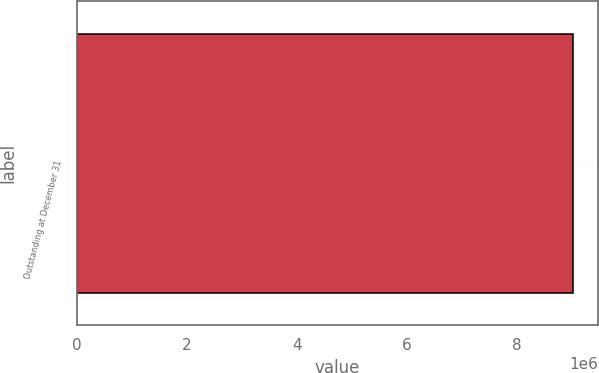<chart> <loc_0><loc_0><loc_500><loc_500><bar_chart><fcel>Outstanding at December 31<nl><fcel>9.01611e+06<nl></chart> 